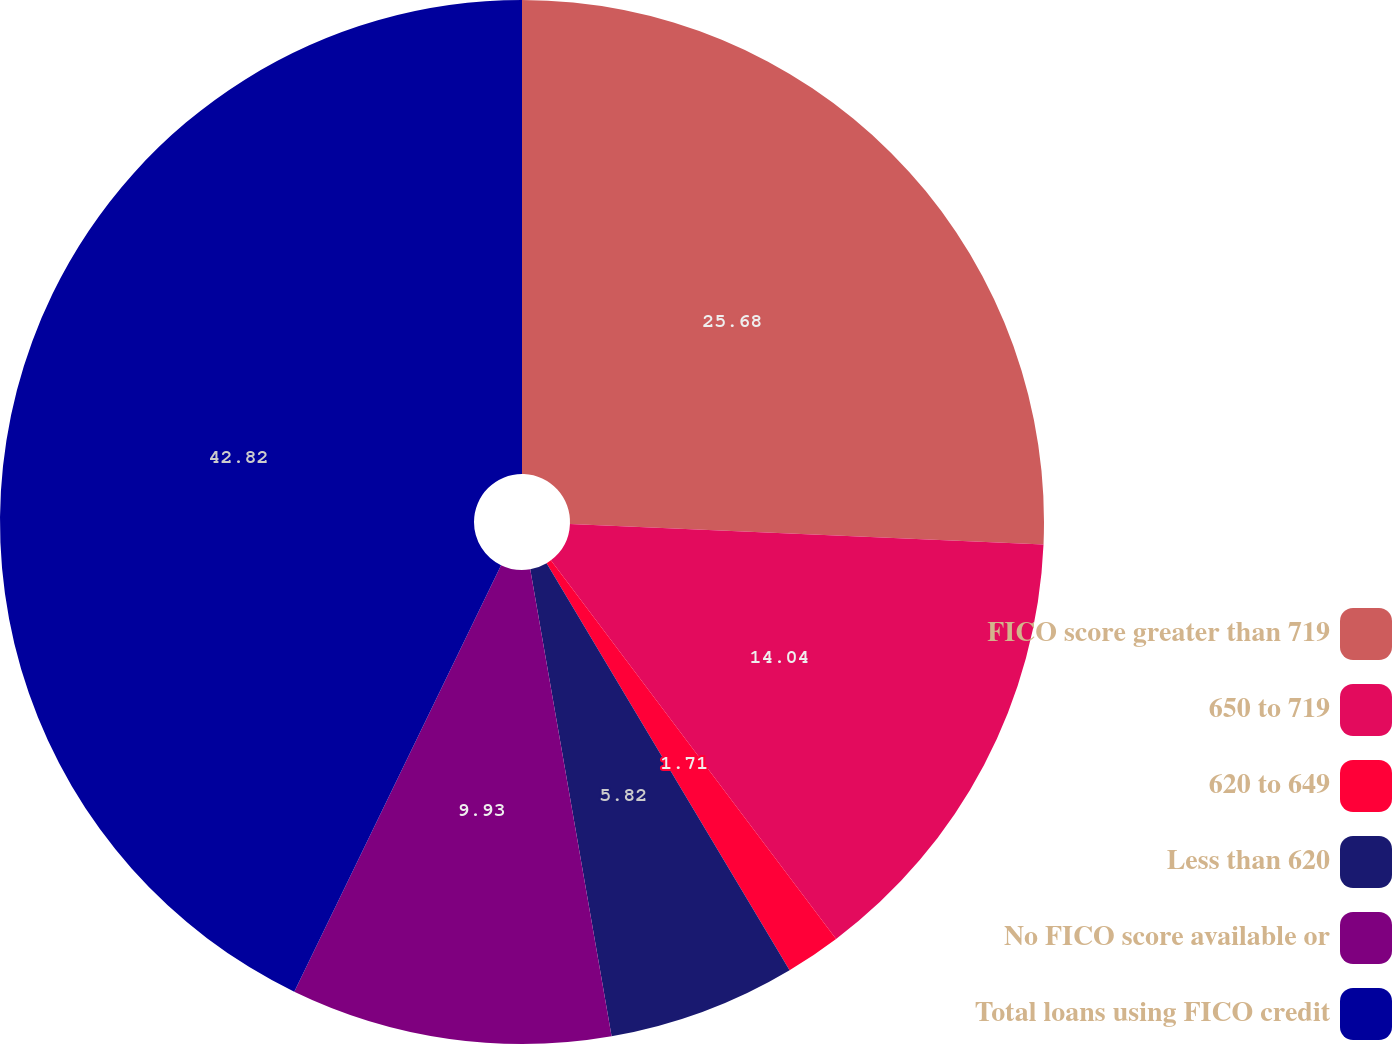<chart> <loc_0><loc_0><loc_500><loc_500><pie_chart><fcel>FICO score greater than 719<fcel>650 to 719<fcel>620 to 649<fcel>Less than 620<fcel>No FICO score available or<fcel>Total loans using FICO credit<nl><fcel>25.68%<fcel>14.04%<fcel>1.71%<fcel>5.82%<fcel>9.93%<fcel>42.81%<nl></chart> 